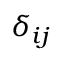<formula> <loc_0><loc_0><loc_500><loc_500>\delta _ { i j }</formula> 